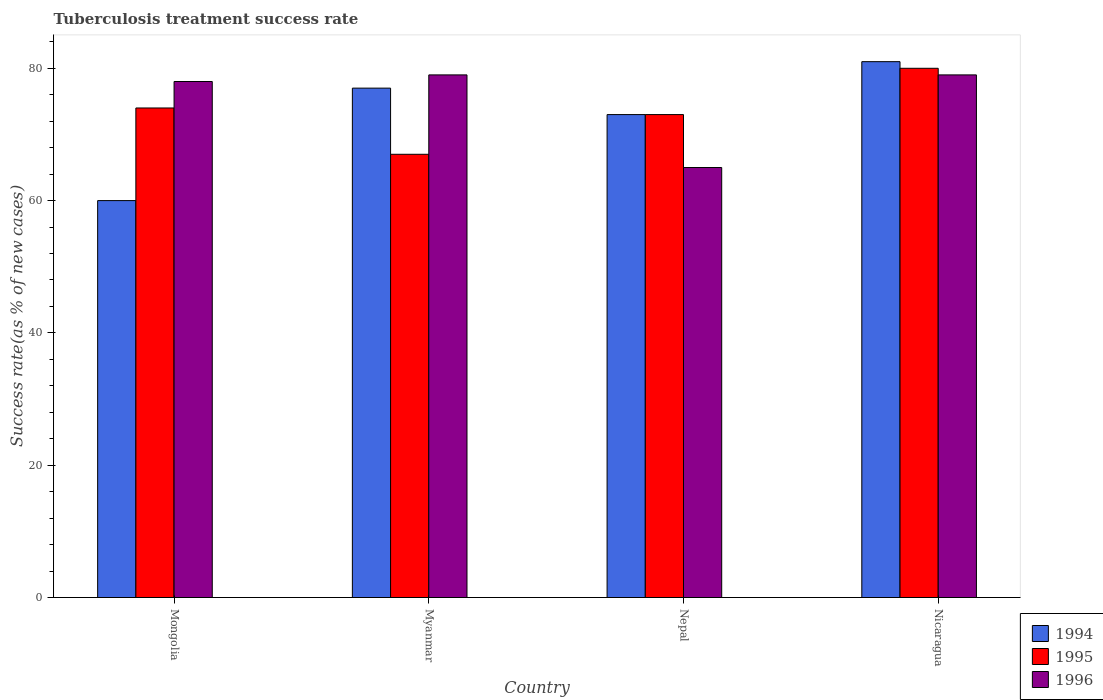How many groups of bars are there?
Your answer should be very brief. 4. What is the label of the 4th group of bars from the left?
Provide a succinct answer. Nicaragua. In how many cases, is the number of bars for a given country not equal to the number of legend labels?
Offer a terse response. 0. What is the tuberculosis treatment success rate in 1994 in Myanmar?
Your answer should be very brief. 77. Across all countries, what is the minimum tuberculosis treatment success rate in 1996?
Your answer should be compact. 65. In which country was the tuberculosis treatment success rate in 1994 maximum?
Give a very brief answer. Nicaragua. In which country was the tuberculosis treatment success rate in 1995 minimum?
Give a very brief answer. Myanmar. What is the total tuberculosis treatment success rate in 1996 in the graph?
Your response must be concise. 301. What is the difference between the tuberculosis treatment success rate in 1994 in Mongolia and that in Nepal?
Your response must be concise. -13. What is the difference between the tuberculosis treatment success rate in 1994 in Nicaragua and the tuberculosis treatment success rate in 1995 in Mongolia?
Offer a very short reply. 7. What is the average tuberculosis treatment success rate in 1994 per country?
Your answer should be compact. 72.75. What is the ratio of the tuberculosis treatment success rate in 1996 in Nepal to that in Nicaragua?
Give a very brief answer. 0.82. Is the tuberculosis treatment success rate in 1994 in Mongolia less than that in Myanmar?
Ensure brevity in your answer.  Yes. What is the difference between the highest and the lowest tuberculosis treatment success rate in 1996?
Provide a short and direct response. 14. In how many countries, is the tuberculosis treatment success rate in 1994 greater than the average tuberculosis treatment success rate in 1994 taken over all countries?
Offer a very short reply. 3. Is the sum of the tuberculosis treatment success rate in 1994 in Mongolia and Nepal greater than the maximum tuberculosis treatment success rate in 1995 across all countries?
Give a very brief answer. Yes. What does the 1st bar from the left in Myanmar represents?
Keep it short and to the point. 1994. How many bars are there?
Make the answer very short. 12. Does the graph contain any zero values?
Your answer should be compact. No. Does the graph contain grids?
Provide a succinct answer. No. Where does the legend appear in the graph?
Your answer should be compact. Bottom right. How are the legend labels stacked?
Offer a terse response. Vertical. What is the title of the graph?
Keep it short and to the point. Tuberculosis treatment success rate. What is the label or title of the Y-axis?
Your answer should be very brief. Success rate(as % of new cases). What is the Success rate(as % of new cases) in 1995 in Mongolia?
Keep it short and to the point. 74. What is the Success rate(as % of new cases) of 1996 in Mongolia?
Your response must be concise. 78. What is the Success rate(as % of new cases) of 1996 in Myanmar?
Your answer should be very brief. 79. What is the Success rate(as % of new cases) in 1994 in Nepal?
Offer a terse response. 73. What is the Success rate(as % of new cases) in 1996 in Nicaragua?
Your answer should be very brief. 79. Across all countries, what is the maximum Success rate(as % of new cases) of 1995?
Provide a short and direct response. 80. Across all countries, what is the maximum Success rate(as % of new cases) of 1996?
Your answer should be very brief. 79. Across all countries, what is the minimum Success rate(as % of new cases) in 1994?
Provide a succinct answer. 60. Across all countries, what is the minimum Success rate(as % of new cases) of 1996?
Offer a terse response. 65. What is the total Success rate(as % of new cases) in 1994 in the graph?
Provide a short and direct response. 291. What is the total Success rate(as % of new cases) in 1995 in the graph?
Provide a succinct answer. 294. What is the total Success rate(as % of new cases) in 1996 in the graph?
Make the answer very short. 301. What is the difference between the Success rate(as % of new cases) of 1994 in Mongolia and that in Myanmar?
Give a very brief answer. -17. What is the difference between the Success rate(as % of new cases) in 1995 in Mongolia and that in Myanmar?
Offer a very short reply. 7. What is the difference between the Success rate(as % of new cases) of 1994 in Mongolia and that in Nepal?
Your answer should be compact. -13. What is the difference between the Success rate(as % of new cases) in 1994 in Mongolia and that in Nicaragua?
Offer a very short reply. -21. What is the difference between the Success rate(as % of new cases) in 1995 in Mongolia and that in Nicaragua?
Offer a terse response. -6. What is the difference between the Success rate(as % of new cases) of 1994 in Myanmar and that in Nepal?
Keep it short and to the point. 4. What is the difference between the Success rate(as % of new cases) of 1994 in Myanmar and that in Nicaragua?
Offer a terse response. -4. What is the difference between the Success rate(as % of new cases) in 1995 in Myanmar and that in Nicaragua?
Offer a very short reply. -13. What is the difference between the Success rate(as % of new cases) in 1996 in Nepal and that in Nicaragua?
Provide a short and direct response. -14. What is the difference between the Success rate(as % of new cases) in 1994 in Mongolia and the Success rate(as % of new cases) in 1995 in Myanmar?
Provide a short and direct response. -7. What is the difference between the Success rate(as % of new cases) in 1995 in Mongolia and the Success rate(as % of new cases) in 1996 in Myanmar?
Make the answer very short. -5. What is the difference between the Success rate(as % of new cases) of 1994 in Mongolia and the Success rate(as % of new cases) of 1995 in Nepal?
Offer a terse response. -13. What is the difference between the Success rate(as % of new cases) of 1995 in Mongolia and the Success rate(as % of new cases) of 1996 in Nepal?
Ensure brevity in your answer.  9. What is the difference between the Success rate(as % of new cases) in 1994 in Mongolia and the Success rate(as % of new cases) in 1995 in Nicaragua?
Provide a succinct answer. -20. What is the difference between the Success rate(as % of new cases) of 1994 in Mongolia and the Success rate(as % of new cases) of 1996 in Nicaragua?
Give a very brief answer. -19. What is the difference between the Success rate(as % of new cases) of 1994 in Myanmar and the Success rate(as % of new cases) of 1995 in Nepal?
Provide a succinct answer. 4. What is the difference between the Success rate(as % of new cases) of 1994 in Myanmar and the Success rate(as % of new cases) of 1996 in Nepal?
Ensure brevity in your answer.  12. What is the difference between the Success rate(as % of new cases) in 1995 in Myanmar and the Success rate(as % of new cases) in 1996 in Nepal?
Your answer should be compact. 2. What is the difference between the Success rate(as % of new cases) of 1994 in Myanmar and the Success rate(as % of new cases) of 1995 in Nicaragua?
Provide a succinct answer. -3. What is the difference between the Success rate(as % of new cases) of 1995 in Myanmar and the Success rate(as % of new cases) of 1996 in Nicaragua?
Provide a succinct answer. -12. What is the difference between the Success rate(as % of new cases) in 1994 in Nepal and the Success rate(as % of new cases) in 1995 in Nicaragua?
Offer a terse response. -7. What is the average Success rate(as % of new cases) in 1994 per country?
Make the answer very short. 72.75. What is the average Success rate(as % of new cases) in 1995 per country?
Your answer should be very brief. 73.5. What is the average Success rate(as % of new cases) of 1996 per country?
Your response must be concise. 75.25. What is the difference between the Success rate(as % of new cases) of 1994 and Success rate(as % of new cases) of 1995 in Mongolia?
Give a very brief answer. -14. What is the difference between the Success rate(as % of new cases) in 1994 and Success rate(as % of new cases) in 1996 in Myanmar?
Your answer should be compact. -2. What is the difference between the Success rate(as % of new cases) of 1994 and Success rate(as % of new cases) of 1995 in Nepal?
Ensure brevity in your answer.  0. What is the difference between the Success rate(as % of new cases) in 1994 and Success rate(as % of new cases) in 1996 in Nepal?
Offer a very short reply. 8. What is the difference between the Success rate(as % of new cases) in 1995 and Success rate(as % of new cases) in 1996 in Nicaragua?
Your answer should be very brief. 1. What is the ratio of the Success rate(as % of new cases) in 1994 in Mongolia to that in Myanmar?
Offer a terse response. 0.78. What is the ratio of the Success rate(as % of new cases) in 1995 in Mongolia to that in Myanmar?
Your answer should be very brief. 1.1. What is the ratio of the Success rate(as % of new cases) in 1996 in Mongolia to that in Myanmar?
Make the answer very short. 0.99. What is the ratio of the Success rate(as % of new cases) in 1994 in Mongolia to that in Nepal?
Give a very brief answer. 0.82. What is the ratio of the Success rate(as % of new cases) in 1995 in Mongolia to that in Nepal?
Your response must be concise. 1.01. What is the ratio of the Success rate(as % of new cases) in 1996 in Mongolia to that in Nepal?
Make the answer very short. 1.2. What is the ratio of the Success rate(as % of new cases) of 1994 in Mongolia to that in Nicaragua?
Make the answer very short. 0.74. What is the ratio of the Success rate(as % of new cases) in 1995 in Mongolia to that in Nicaragua?
Offer a very short reply. 0.93. What is the ratio of the Success rate(as % of new cases) of 1996 in Mongolia to that in Nicaragua?
Ensure brevity in your answer.  0.99. What is the ratio of the Success rate(as % of new cases) of 1994 in Myanmar to that in Nepal?
Offer a terse response. 1.05. What is the ratio of the Success rate(as % of new cases) of 1995 in Myanmar to that in Nepal?
Your answer should be very brief. 0.92. What is the ratio of the Success rate(as % of new cases) in 1996 in Myanmar to that in Nepal?
Make the answer very short. 1.22. What is the ratio of the Success rate(as % of new cases) in 1994 in Myanmar to that in Nicaragua?
Offer a very short reply. 0.95. What is the ratio of the Success rate(as % of new cases) in 1995 in Myanmar to that in Nicaragua?
Make the answer very short. 0.84. What is the ratio of the Success rate(as % of new cases) in 1996 in Myanmar to that in Nicaragua?
Provide a succinct answer. 1. What is the ratio of the Success rate(as % of new cases) of 1994 in Nepal to that in Nicaragua?
Your response must be concise. 0.9. What is the ratio of the Success rate(as % of new cases) of 1995 in Nepal to that in Nicaragua?
Your answer should be compact. 0.91. What is the ratio of the Success rate(as % of new cases) of 1996 in Nepal to that in Nicaragua?
Provide a succinct answer. 0.82. What is the difference between the highest and the second highest Success rate(as % of new cases) in 1994?
Give a very brief answer. 4. What is the difference between the highest and the second highest Success rate(as % of new cases) in 1995?
Keep it short and to the point. 6. What is the difference between the highest and the second highest Success rate(as % of new cases) of 1996?
Your response must be concise. 0. What is the difference between the highest and the lowest Success rate(as % of new cases) in 1995?
Provide a succinct answer. 13. 